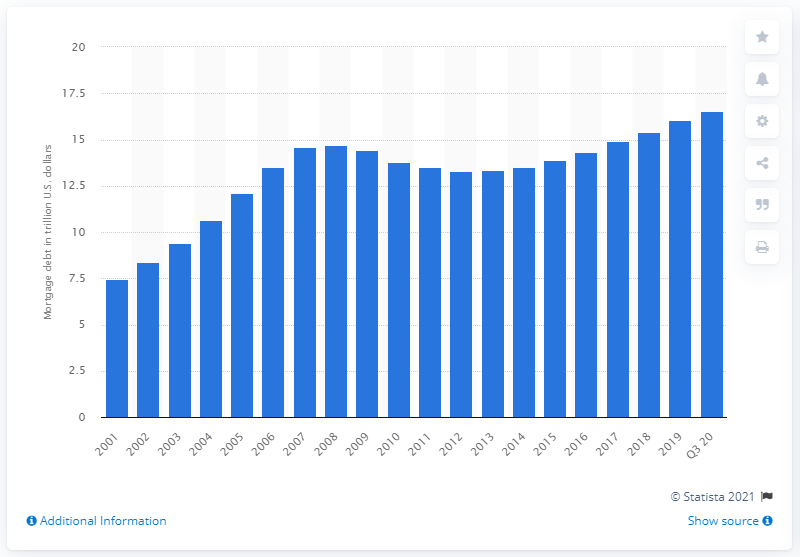Draw attention to some important aspects in this diagram. In the third quarter of 2020, the total outstanding mortgage debt in the United States was approximately 16.56. In 2001, the total mortgage debt outstanding in the United States was recorded. 